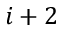<formula> <loc_0><loc_0><loc_500><loc_500>i + 2</formula> 